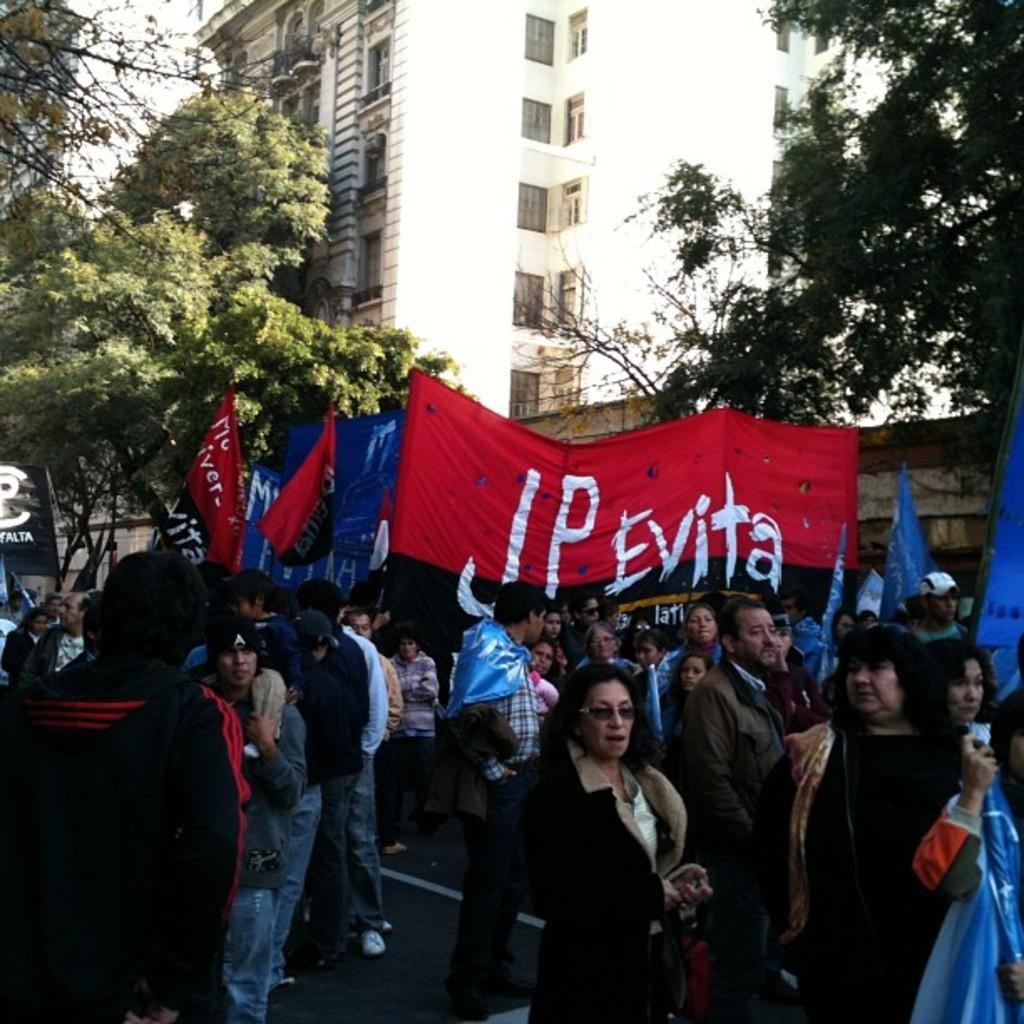Could you give a brief overview of what you see in this image? In this image there are group of persons standing and walking holding banners with some text written on it. In the background there is a building and there are trees. 